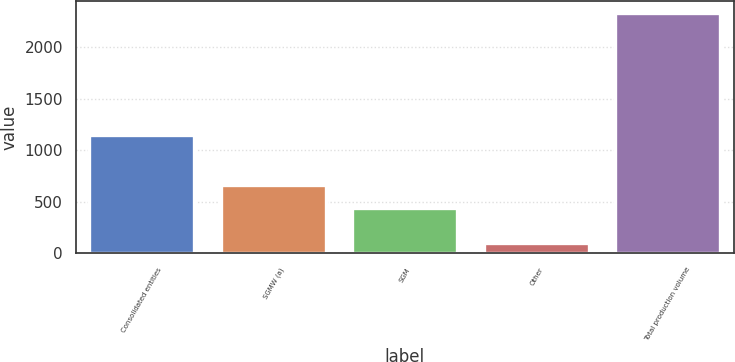<chart> <loc_0><loc_0><loc_500><loc_500><bar_chart><fcel>Consolidated entities<fcel>SGMW (a)<fcel>SGM<fcel>Other<fcel>Total production volume<nl><fcel>1153<fcel>662.8<fcel>439<fcel>97<fcel>2335<nl></chart> 